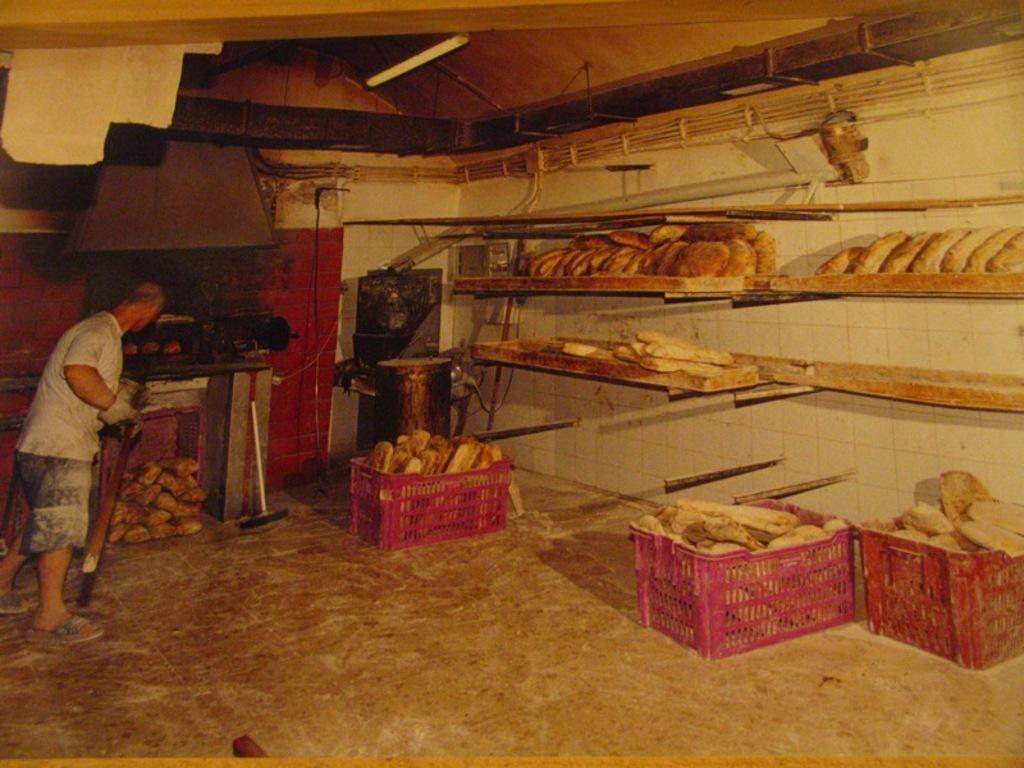Could you give a brief overview of what you see in this image? In this picture we can see a person holding a stick with his hand, standing on the floor, baskets, shelves, roof, some objects and in the background we can see the walls. 